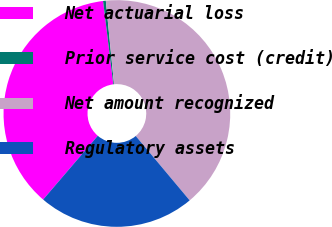<chart> <loc_0><loc_0><loc_500><loc_500><pie_chart><fcel>Net actuarial loss<fcel>Prior service cost (credit)<fcel>Net amount recognized<fcel>Regulatory assets<nl><fcel>36.78%<fcel>0.39%<fcel>40.46%<fcel>22.37%<nl></chart> 